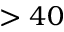<formula> <loc_0><loc_0><loc_500><loc_500>> 4 0</formula> 